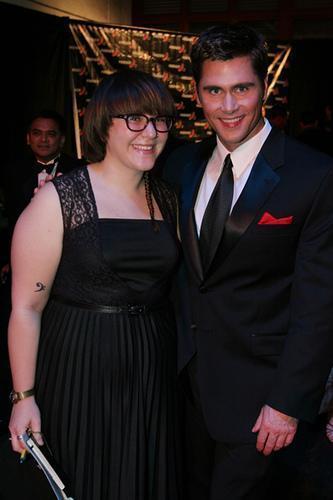How many people can be seen?
Give a very brief answer. 3. 